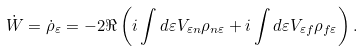<formula> <loc_0><loc_0><loc_500><loc_500>\dot { W } = \dot { \rho } _ { \varepsilon } = - 2 \Re \left ( i \int d \varepsilon V _ { \varepsilon n } \rho _ { n \varepsilon } + i \int d \varepsilon V _ { \varepsilon f } \rho _ { f \varepsilon } \right ) .</formula> 